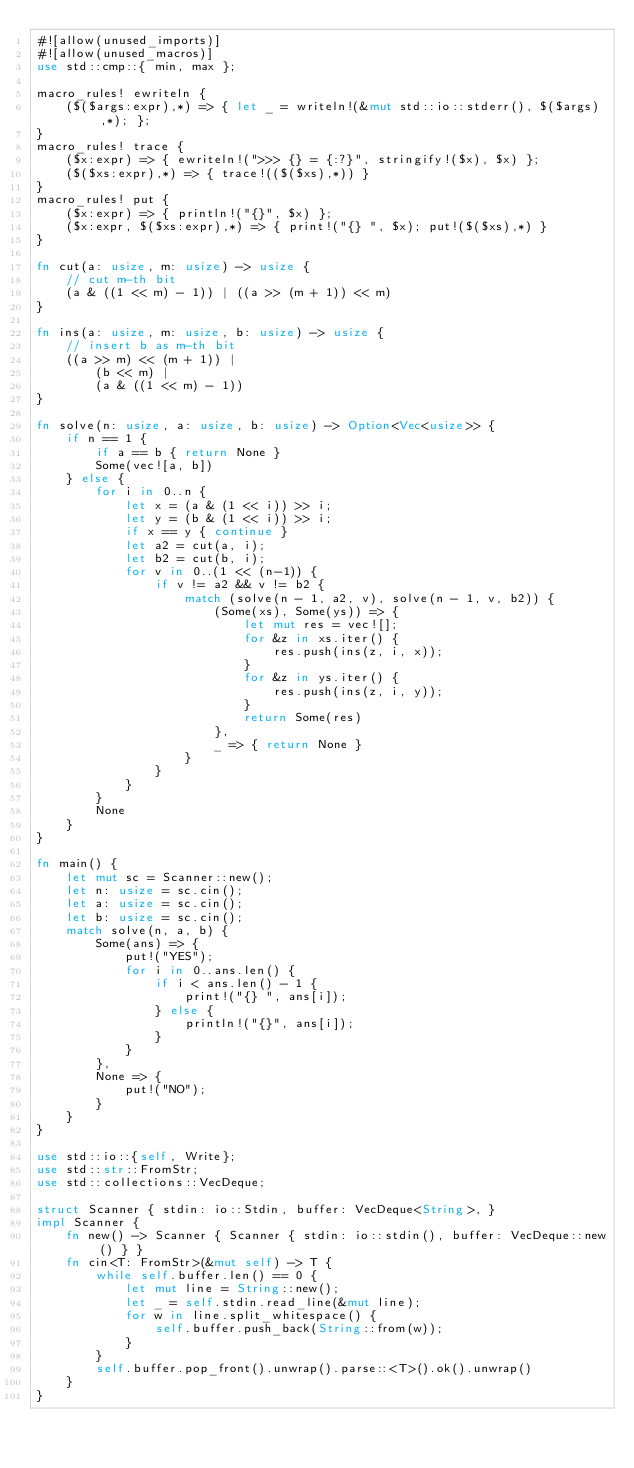<code> <loc_0><loc_0><loc_500><loc_500><_Rust_>#![allow(unused_imports)]
#![allow(unused_macros)]
use std::cmp::{ min, max };

macro_rules! ewriteln {
    ($($args:expr),*) => { let _ = writeln!(&mut std::io::stderr(), $($args),*); };
}
macro_rules! trace {
    ($x:expr) => { ewriteln!(">>> {} = {:?}", stringify!($x), $x) };
    ($($xs:expr),*) => { trace!(($($xs),*)) }
}
macro_rules! put {
    ($x:expr) => { println!("{}", $x) };
    ($x:expr, $($xs:expr),*) => { print!("{} ", $x); put!($($xs),*) }
}

fn cut(a: usize, m: usize) -> usize {
    // cut m-th bit
    (a & ((1 << m) - 1)) | ((a >> (m + 1)) << m)
}

fn ins(a: usize, m: usize, b: usize) -> usize {
    // insert b as m-th bit
    ((a >> m) << (m + 1)) |
        (b << m) |
        (a & ((1 << m) - 1))
}

fn solve(n: usize, a: usize, b: usize) -> Option<Vec<usize>> {
    if n == 1 {
        if a == b { return None }
        Some(vec![a, b])
    } else {
        for i in 0..n {
            let x = (a & (1 << i)) >> i;
            let y = (b & (1 << i)) >> i;
            if x == y { continue }
            let a2 = cut(a, i);
            let b2 = cut(b, i);
            for v in 0..(1 << (n-1)) {
                if v != a2 && v != b2 {
                    match (solve(n - 1, a2, v), solve(n - 1, v, b2)) {
                        (Some(xs), Some(ys)) => {
                            let mut res = vec![];
                            for &z in xs.iter() {
                                res.push(ins(z, i, x));
                            }
                            for &z in ys.iter() {
                                res.push(ins(z, i, y));
                            }
                            return Some(res)
                        },
                        _ => { return None }
                    }
                }
            }
        }
        None
    }
}

fn main() {
    let mut sc = Scanner::new();
    let n: usize = sc.cin();
    let a: usize = sc.cin();
    let b: usize = sc.cin();
    match solve(n, a, b) {
        Some(ans) => {
            put!("YES");
            for i in 0..ans.len() {
                if i < ans.len() - 1 {
                    print!("{} ", ans[i]);
                } else {
                    println!("{}", ans[i]);
                }
            }
        },
        None => {
            put!("NO");
        }
    }
}

use std::io::{self, Write};
use std::str::FromStr;
use std::collections::VecDeque;

struct Scanner { stdin: io::Stdin, buffer: VecDeque<String>, }
impl Scanner {
    fn new() -> Scanner { Scanner { stdin: io::stdin(), buffer: VecDeque::new() } }
    fn cin<T: FromStr>(&mut self) -> T {
        while self.buffer.len() == 0 {
            let mut line = String::new();
            let _ = self.stdin.read_line(&mut line);
            for w in line.split_whitespace() {
                self.buffer.push_back(String::from(w));
            }
        }
        self.buffer.pop_front().unwrap().parse::<T>().ok().unwrap()
    }
}
</code> 